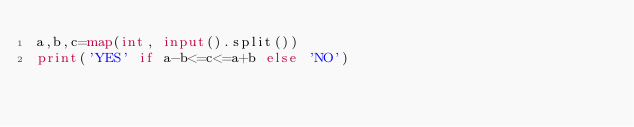Convert code to text. <code><loc_0><loc_0><loc_500><loc_500><_Python_>a,b,c=map(int, input().split())
print('YES' if a-b<=c<=a+b else 'NO')</code> 